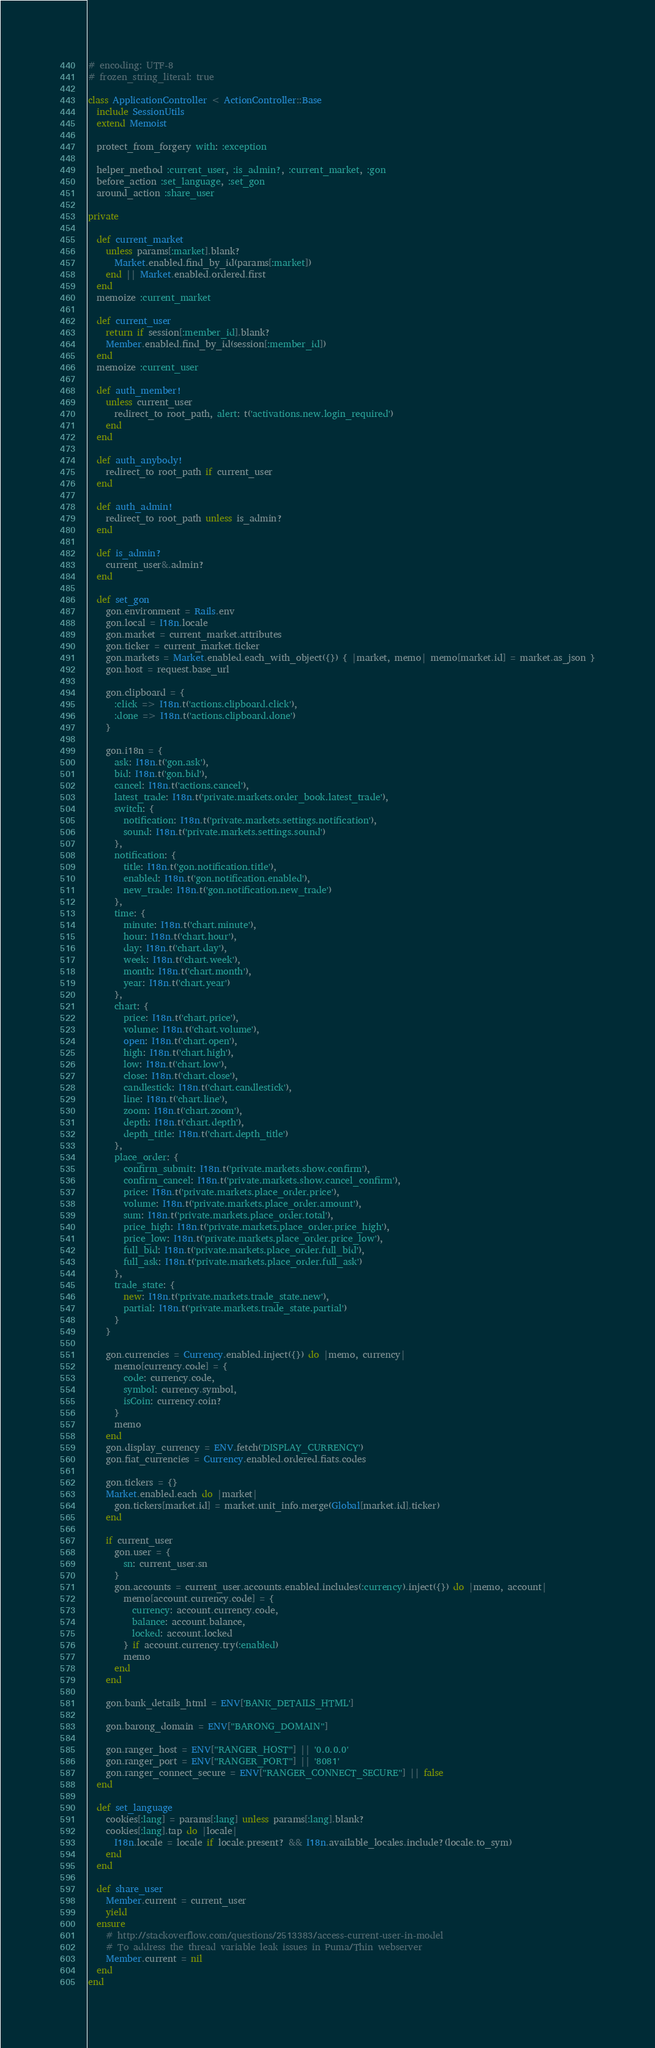<code> <loc_0><loc_0><loc_500><loc_500><_Ruby_># encoding: UTF-8
# frozen_string_literal: true

class ApplicationController < ActionController::Base
  include SessionUtils
  extend Memoist

  protect_from_forgery with: :exception

  helper_method :current_user, :is_admin?, :current_market, :gon
  before_action :set_language, :set_gon
  around_action :share_user

private

  def current_market
    unless params[:market].blank?
      Market.enabled.find_by_id(params[:market])
    end || Market.enabled.ordered.first
  end
  memoize :current_market

  def current_user
    return if session[:member_id].blank?
    Member.enabled.find_by_id(session[:member_id])
  end
  memoize :current_user

  def auth_member!
    unless current_user
      redirect_to root_path, alert: t('activations.new.login_required')
    end
  end

  def auth_anybody!
    redirect_to root_path if current_user
  end

  def auth_admin!
    redirect_to root_path unless is_admin?
  end

  def is_admin?
    current_user&.admin?
  end

  def set_gon
    gon.environment = Rails.env
    gon.local = I18n.locale
    gon.market = current_market.attributes
    gon.ticker = current_market.ticker
    gon.markets = Market.enabled.each_with_object({}) { |market, memo| memo[market.id] = market.as_json }
    gon.host = request.base_url

    gon.clipboard = {
      :click => I18n.t('actions.clipboard.click'),
      :done => I18n.t('actions.clipboard.done')
    }

    gon.i18n = {
      ask: I18n.t('gon.ask'),
      bid: I18n.t('gon.bid'),
      cancel: I18n.t('actions.cancel'),
      latest_trade: I18n.t('private.markets.order_book.latest_trade'),
      switch: {
        notification: I18n.t('private.markets.settings.notification'),
        sound: I18n.t('private.markets.settings.sound')
      },
      notification: {
        title: I18n.t('gon.notification.title'),
        enabled: I18n.t('gon.notification.enabled'),
        new_trade: I18n.t('gon.notification.new_trade')
      },
      time: {
        minute: I18n.t('chart.minute'),
        hour: I18n.t('chart.hour'),
        day: I18n.t('chart.day'),
        week: I18n.t('chart.week'),
        month: I18n.t('chart.month'),
        year: I18n.t('chart.year')
      },
      chart: {
        price: I18n.t('chart.price'),
        volume: I18n.t('chart.volume'),
        open: I18n.t('chart.open'),
        high: I18n.t('chart.high'),
        low: I18n.t('chart.low'),
        close: I18n.t('chart.close'),
        candlestick: I18n.t('chart.candlestick'),
        line: I18n.t('chart.line'),
        zoom: I18n.t('chart.zoom'),
        depth: I18n.t('chart.depth'),
        depth_title: I18n.t('chart.depth_title')
      },
      place_order: {
        confirm_submit: I18n.t('private.markets.show.confirm'),
        confirm_cancel: I18n.t('private.markets.show.cancel_confirm'),
        price: I18n.t('private.markets.place_order.price'),
        volume: I18n.t('private.markets.place_order.amount'),
        sum: I18n.t('private.markets.place_order.total'),
        price_high: I18n.t('private.markets.place_order.price_high'),
        price_low: I18n.t('private.markets.place_order.price_low'),
        full_bid: I18n.t('private.markets.place_order.full_bid'),
        full_ask: I18n.t('private.markets.place_order.full_ask')
      },
      trade_state: {
        new: I18n.t('private.markets.trade_state.new'),
        partial: I18n.t('private.markets.trade_state.partial')
      }
    }

    gon.currencies = Currency.enabled.inject({}) do |memo, currency|
      memo[currency.code] = {
        code: currency.code,
        symbol: currency.symbol,
        isCoin: currency.coin?
      }
      memo
    end
    gon.display_currency = ENV.fetch('DISPLAY_CURRENCY')
    gon.fiat_currencies = Currency.enabled.ordered.fiats.codes

    gon.tickers = {}
    Market.enabled.each do |market|
      gon.tickers[market.id] = market.unit_info.merge(Global[market.id].ticker)
    end

    if current_user
      gon.user = {
        sn: current_user.sn
      }
      gon.accounts = current_user.accounts.enabled.includes(:currency).inject({}) do |memo, account|
        memo[account.currency.code] = {
          currency: account.currency.code,
          balance: account.balance,
          locked: account.locked
        } if account.currency.try(:enabled)
        memo
      end
    end

    gon.bank_details_html = ENV['BANK_DETAILS_HTML']

    gon.barong_domain = ENV["BARONG_DOMAIN"]

    gon.ranger_host = ENV["RANGER_HOST"] || '0.0.0.0'
    gon.ranger_port = ENV["RANGER_PORT"] || '8081'
    gon.ranger_connect_secure = ENV["RANGER_CONNECT_SECURE"] || false
  end

  def set_language
    cookies[:lang] = params[:lang] unless params[:lang].blank?
    cookies[:lang].tap do |locale|
      I18n.locale = locale if locale.present? && I18n.available_locales.include?(locale.to_sym)
    end
  end

  def share_user
    Member.current = current_user
    yield
  ensure
    # http://stackoverflow.com/questions/2513383/access-current-user-in-model
    # To address the thread variable leak issues in Puma/Thin webserver
    Member.current = nil
  end
end
</code> 